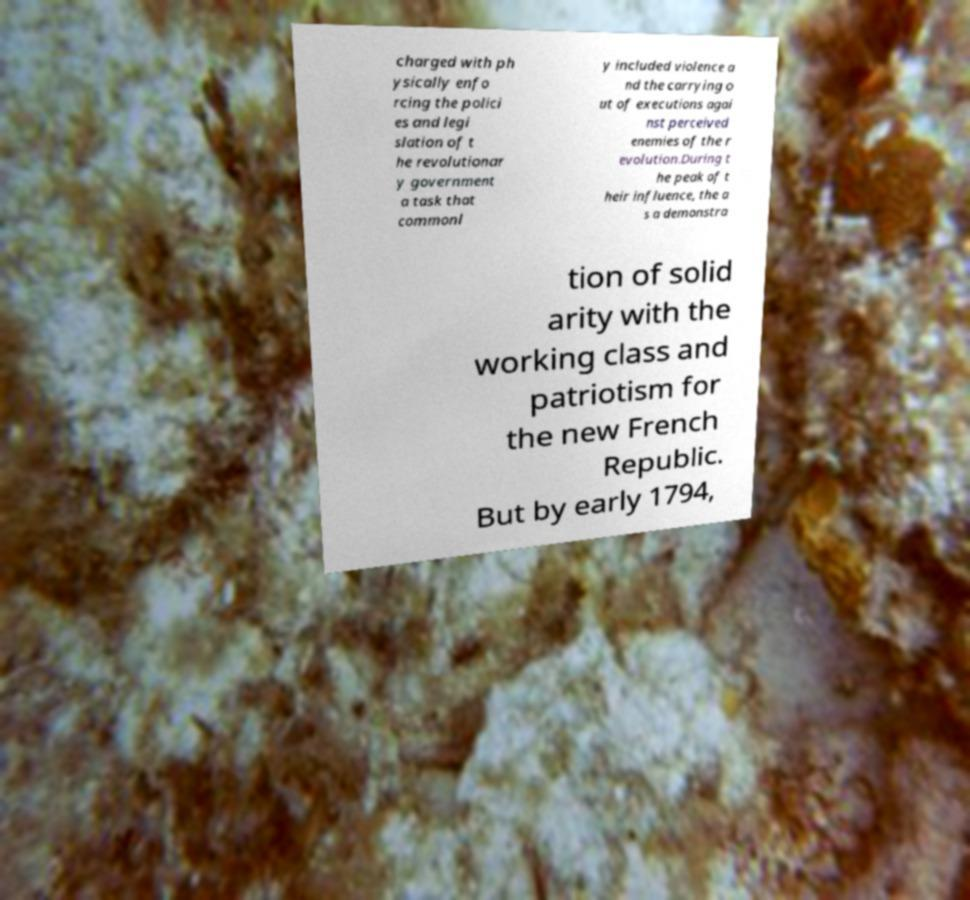Can you accurately transcribe the text from the provided image for me? charged with ph ysically enfo rcing the polici es and legi slation of t he revolutionar y government a task that commonl y included violence a nd the carrying o ut of executions agai nst perceived enemies of the r evolution.During t he peak of t heir influence, the a s a demonstra tion of solid arity with the working class and patriotism for the new French Republic. But by early 1794, 